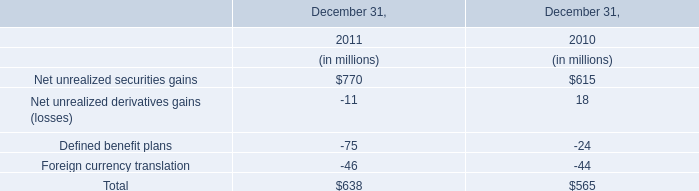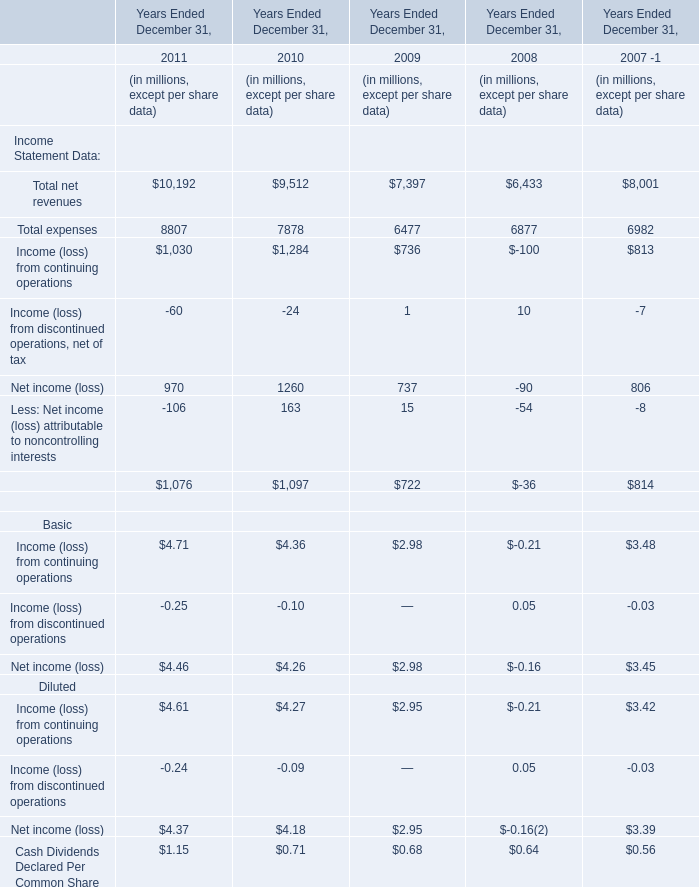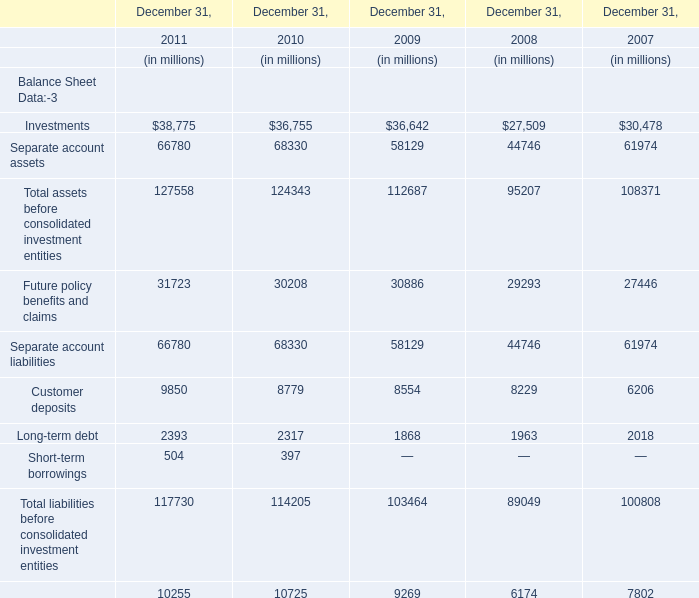In the year with the most continuing operations, what is the growth rate of net income? 
Computations: ((1260 - 737) / 737)
Answer: 0.70963. 